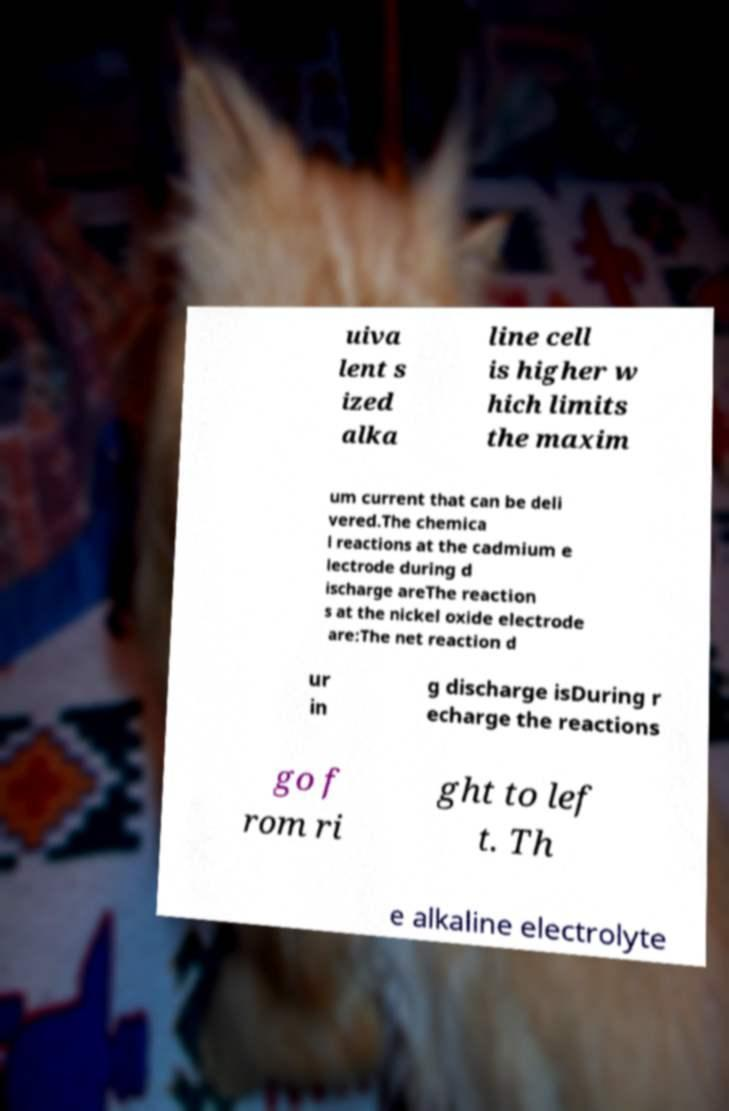Please read and relay the text visible in this image. What does it say? uiva lent s ized alka line cell is higher w hich limits the maxim um current that can be deli vered.The chemica l reactions at the cadmium e lectrode during d ischarge areThe reaction s at the nickel oxide electrode are:The net reaction d ur in g discharge isDuring r echarge the reactions go f rom ri ght to lef t. Th e alkaline electrolyte 